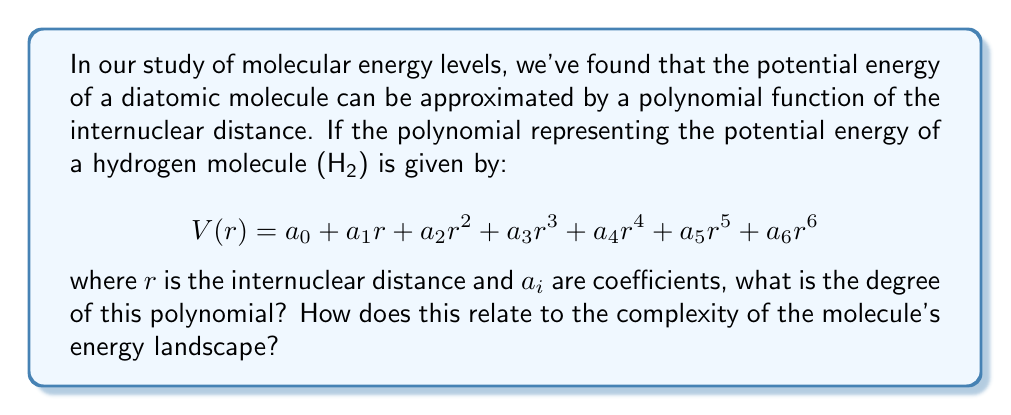Can you solve this math problem? To determine the degree of the polynomial, we follow these steps:

1) The degree of a polynomial is defined as the highest power of the variable in the polynomial.

2) In this case, the variable is $r$ (representing the internuclear distance).

3) We examine each term in the polynomial:
   - $a_0$ is a constant term (degree 0)
   - $a_1r$ has degree 1
   - $a_2r^2$ has degree 2
   - $a_3r^3$ has degree 3
   - $a_4r^4$ has degree 4
   - $a_5r^5$ has degree 5
   - $a_6r^6$ has degree 6

4) The highest power of $r$ is 6, which appears in the last term $a_6r^6$.

5) Therefore, the degree of this polynomial is 6.

Relating this to the complexity of the molecule's energy landscape:

6) A higher degree polynomial can capture more complex behavior in the potential energy surface.

7) For a diatomic molecule like H₂, a 6th degree polynomial is quite sophisticated, allowing for accurate representation of anharmonicity in the molecular vibrations and a good description of the dissociation limit.

8) This level of complexity is often necessary for quantitative predictions in quantum chemistry calculations, as it can account for subtle effects in the molecular energy levels that simpler models might miss.
Answer: 6 